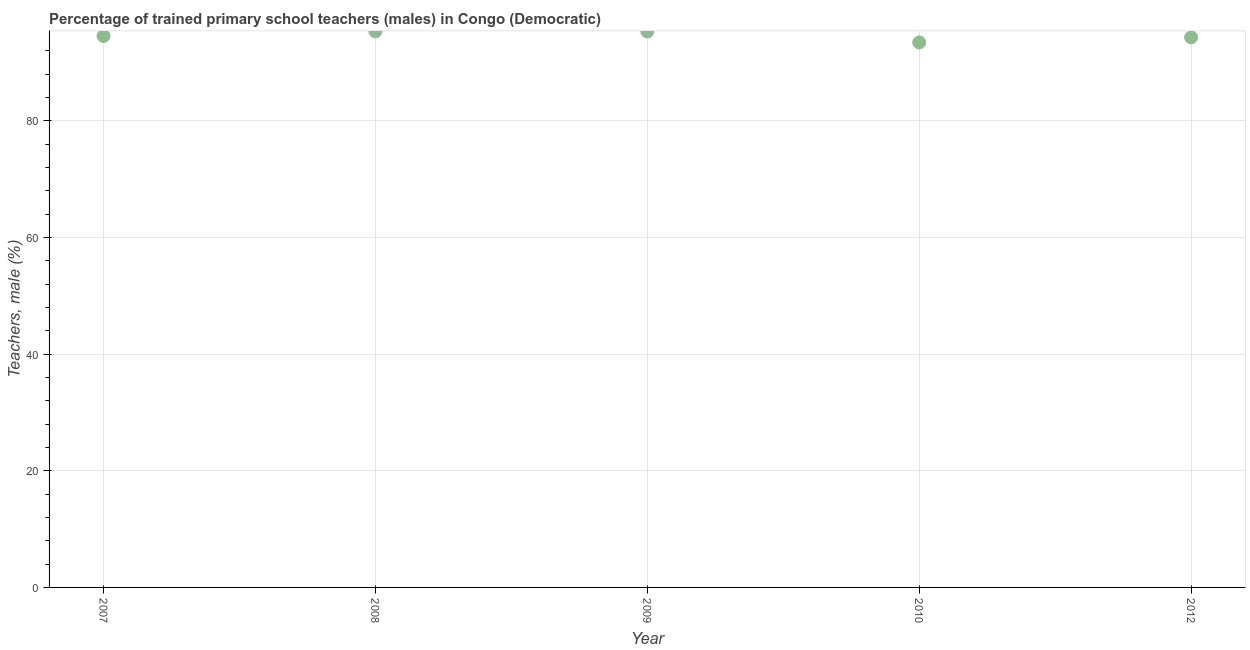What is the percentage of trained male teachers in 2012?
Give a very brief answer. 94.31. Across all years, what is the maximum percentage of trained male teachers?
Your response must be concise. 95.33. Across all years, what is the minimum percentage of trained male teachers?
Give a very brief answer. 93.44. What is the sum of the percentage of trained male teachers?
Offer a terse response. 472.93. What is the difference between the percentage of trained male teachers in 2008 and 2009?
Your answer should be compact. 0.02. What is the average percentage of trained male teachers per year?
Your response must be concise. 94.59. What is the median percentage of trained male teachers?
Give a very brief answer. 94.54. Do a majority of the years between 2007 and 2008 (inclusive) have percentage of trained male teachers greater than 48 %?
Offer a very short reply. Yes. What is the ratio of the percentage of trained male teachers in 2008 to that in 2012?
Keep it short and to the point. 1.01. Is the difference between the percentage of trained male teachers in 2009 and 2010 greater than the difference between any two years?
Ensure brevity in your answer.  No. What is the difference between the highest and the second highest percentage of trained male teachers?
Provide a succinct answer. 0.02. Is the sum of the percentage of trained male teachers in 2008 and 2009 greater than the maximum percentage of trained male teachers across all years?
Your response must be concise. Yes. What is the difference between the highest and the lowest percentage of trained male teachers?
Your answer should be very brief. 1.89. What is the difference between two consecutive major ticks on the Y-axis?
Ensure brevity in your answer.  20. Are the values on the major ticks of Y-axis written in scientific E-notation?
Make the answer very short. No. Does the graph contain grids?
Provide a succinct answer. Yes. What is the title of the graph?
Provide a short and direct response. Percentage of trained primary school teachers (males) in Congo (Democratic). What is the label or title of the X-axis?
Make the answer very short. Year. What is the label or title of the Y-axis?
Your response must be concise. Teachers, male (%). What is the Teachers, male (%) in 2007?
Offer a very short reply. 94.54. What is the Teachers, male (%) in 2008?
Your answer should be very brief. 95.33. What is the Teachers, male (%) in 2009?
Offer a very short reply. 95.32. What is the Teachers, male (%) in 2010?
Your response must be concise. 93.44. What is the Teachers, male (%) in 2012?
Give a very brief answer. 94.31. What is the difference between the Teachers, male (%) in 2007 and 2008?
Provide a short and direct response. -0.8. What is the difference between the Teachers, male (%) in 2007 and 2009?
Provide a short and direct response. -0.78. What is the difference between the Teachers, male (%) in 2007 and 2010?
Ensure brevity in your answer.  1.1. What is the difference between the Teachers, male (%) in 2007 and 2012?
Your answer should be compact. 0.23. What is the difference between the Teachers, male (%) in 2008 and 2009?
Your answer should be compact. 0.02. What is the difference between the Teachers, male (%) in 2008 and 2010?
Your answer should be compact. 1.89. What is the difference between the Teachers, male (%) in 2008 and 2012?
Ensure brevity in your answer.  1.03. What is the difference between the Teachers, male (%) in 2009 and 2010?
Provide a succinct answer. 1.88. What is the difference between the Teachers, male (%) in 2009 and 2012?
Provide a short and direct response. 1.01. What is the difference between the Teachers, male (%) in 2010 and 2012?
Offer a very short reply. -0.87. What is the ratio of the Teachers, male (%) in 2007 to that in 2009?
Make the answer very short. 0.99. What is the ratio of the Teachers, male (%) in 2008 to that in 2010?
Your response must be concise. 1.02. What is the ratio of the Teachers, male (%) in 2010 to that in 2012?
Give a very brief answer. 0.99. 